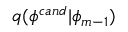<formula> <loc_0><loc_0><loc_500><loc_500>q ( \phi ^ { c a n d } | \phi _ { m - 1 } )</formula> 